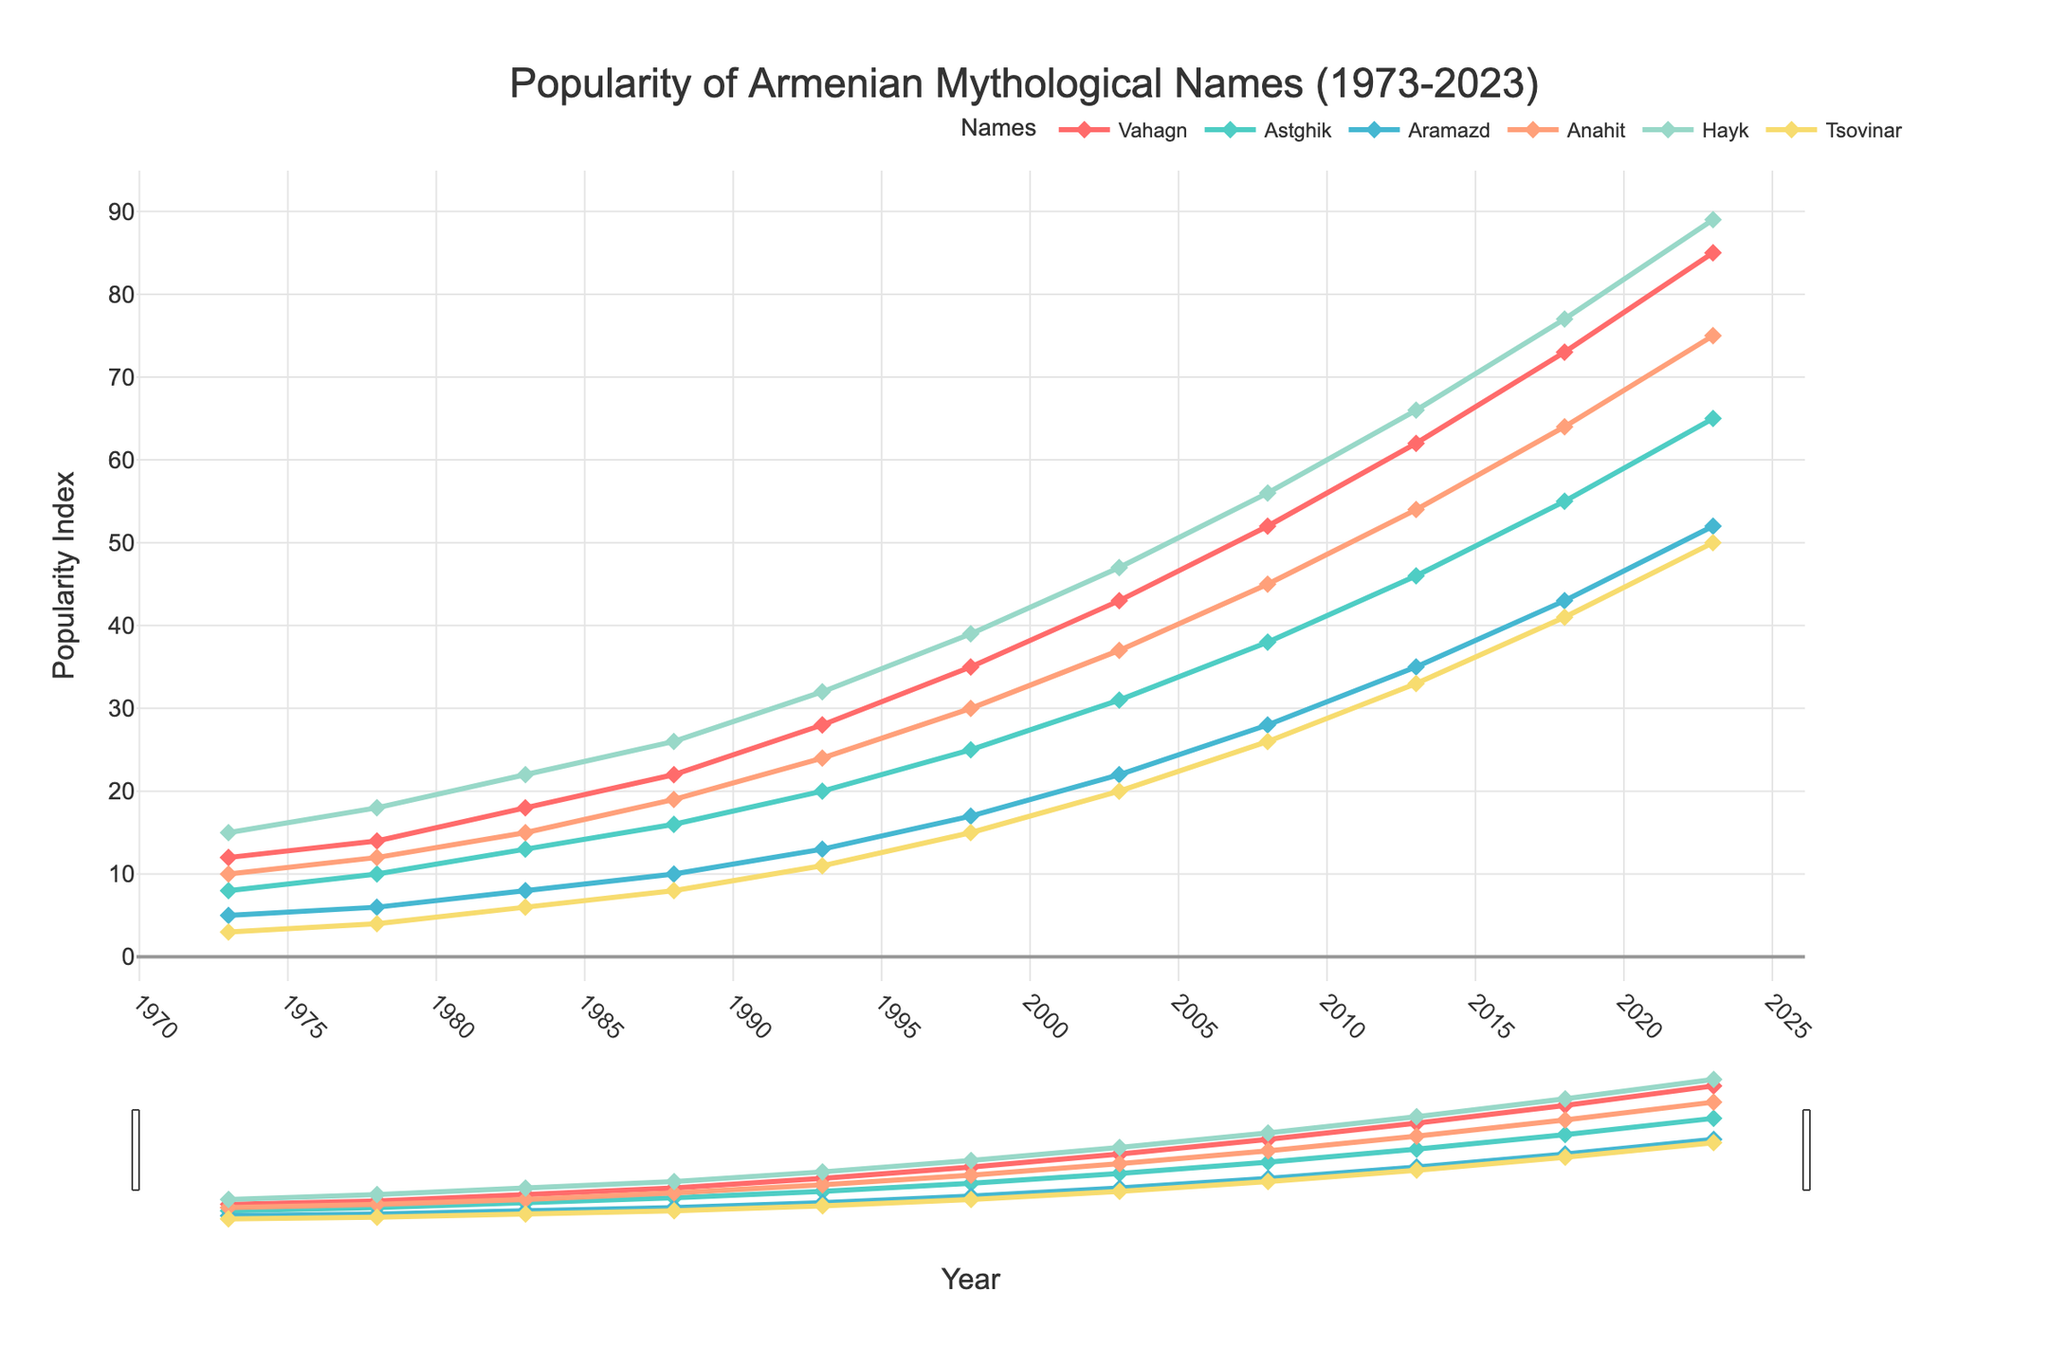Which name has the highest popularity in 2023? The figure shows the popularity of various Armenian mythological names over time. In 2023, the name with the highest value is the one with the greatest y-axis coordinate.
Answer: Hayk Which name had the lowest popularity in 1973? In the year 1973, the name with the smallest value on the y-axis has the lowest popularity.
Answer: Tsovinar How did the popularity of Anahit change between 1983 and 2008? Look up the popularity values for Anahit in 1983 and 2008, then calculate the difference (subtract the 1983 value from the 2008 value).
Answer: Increased by 30 (from 15 to 45) What is the average popularity of Astghik between 1973 and 2023? Sum the popularity of Astghik for years 1973 through 2023, then divide by the number of data points (11 years).
Answer: 32.91 Which name demonstrated the greatest increase in popularity from 1998 to 2023? For each name, subtract the 1998 value from the 2023 value. The name with the largest result shows the greatest increase.
Answer: Hayk Compare the popularity of Vahagn and Aramazd in 2013. Which one is more popular and by how much? Compare the y-axis values for Vahagn and Aramazd in 2013 and find the difference between them.
Answer: Vahagn is more popular by 27 (62 vs. 35) Which name consistently gained popularity over every 5-year interval? Check the values for each name at each 5-year mark and confirm they increased every interval.
Answer: Hayk Is there a name that remained less popular than all others in each year of the dataset? By comparing the numeric values across all years, identify if any single name is consistently the lowest.
Answer: Tsovinar What is the total increase in popularity for Tsovinar from 1973 to 2023? Subtract the 1973 value of Tsovinar from the 2023 value.
Answer: 47 (50 - 3) Which name had the most significant decline in popularity at any point? Identify any intervals in which popularity declined for any name, then find the maximum decrease by calculating the difference.
Answer: No names show a decline 